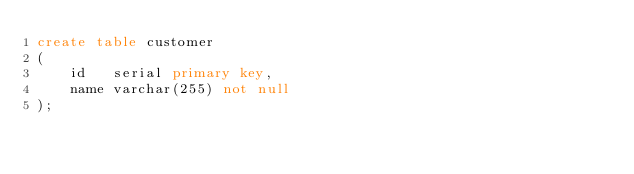Convert code to text. <code><loc_0><loc_0><loc_500><loc_500><_SQL_>create table customer
(
    id   serial primary key,
    name varchar(255) not null
);</code> 